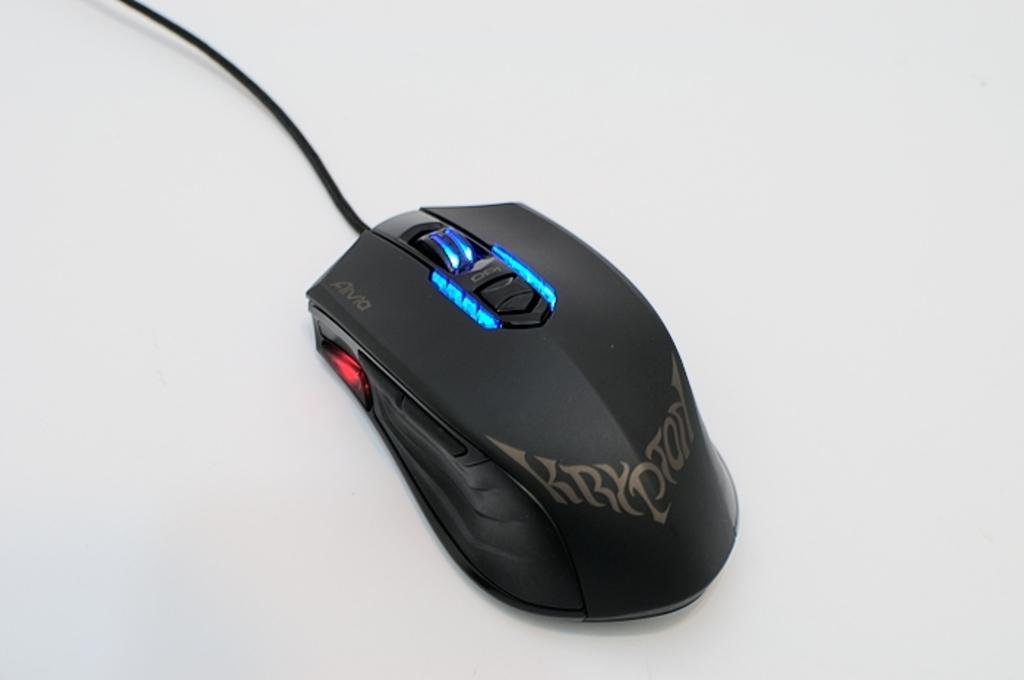<image>
Summarize the visual content of the image. a computer mouse with the word Krypton on it 